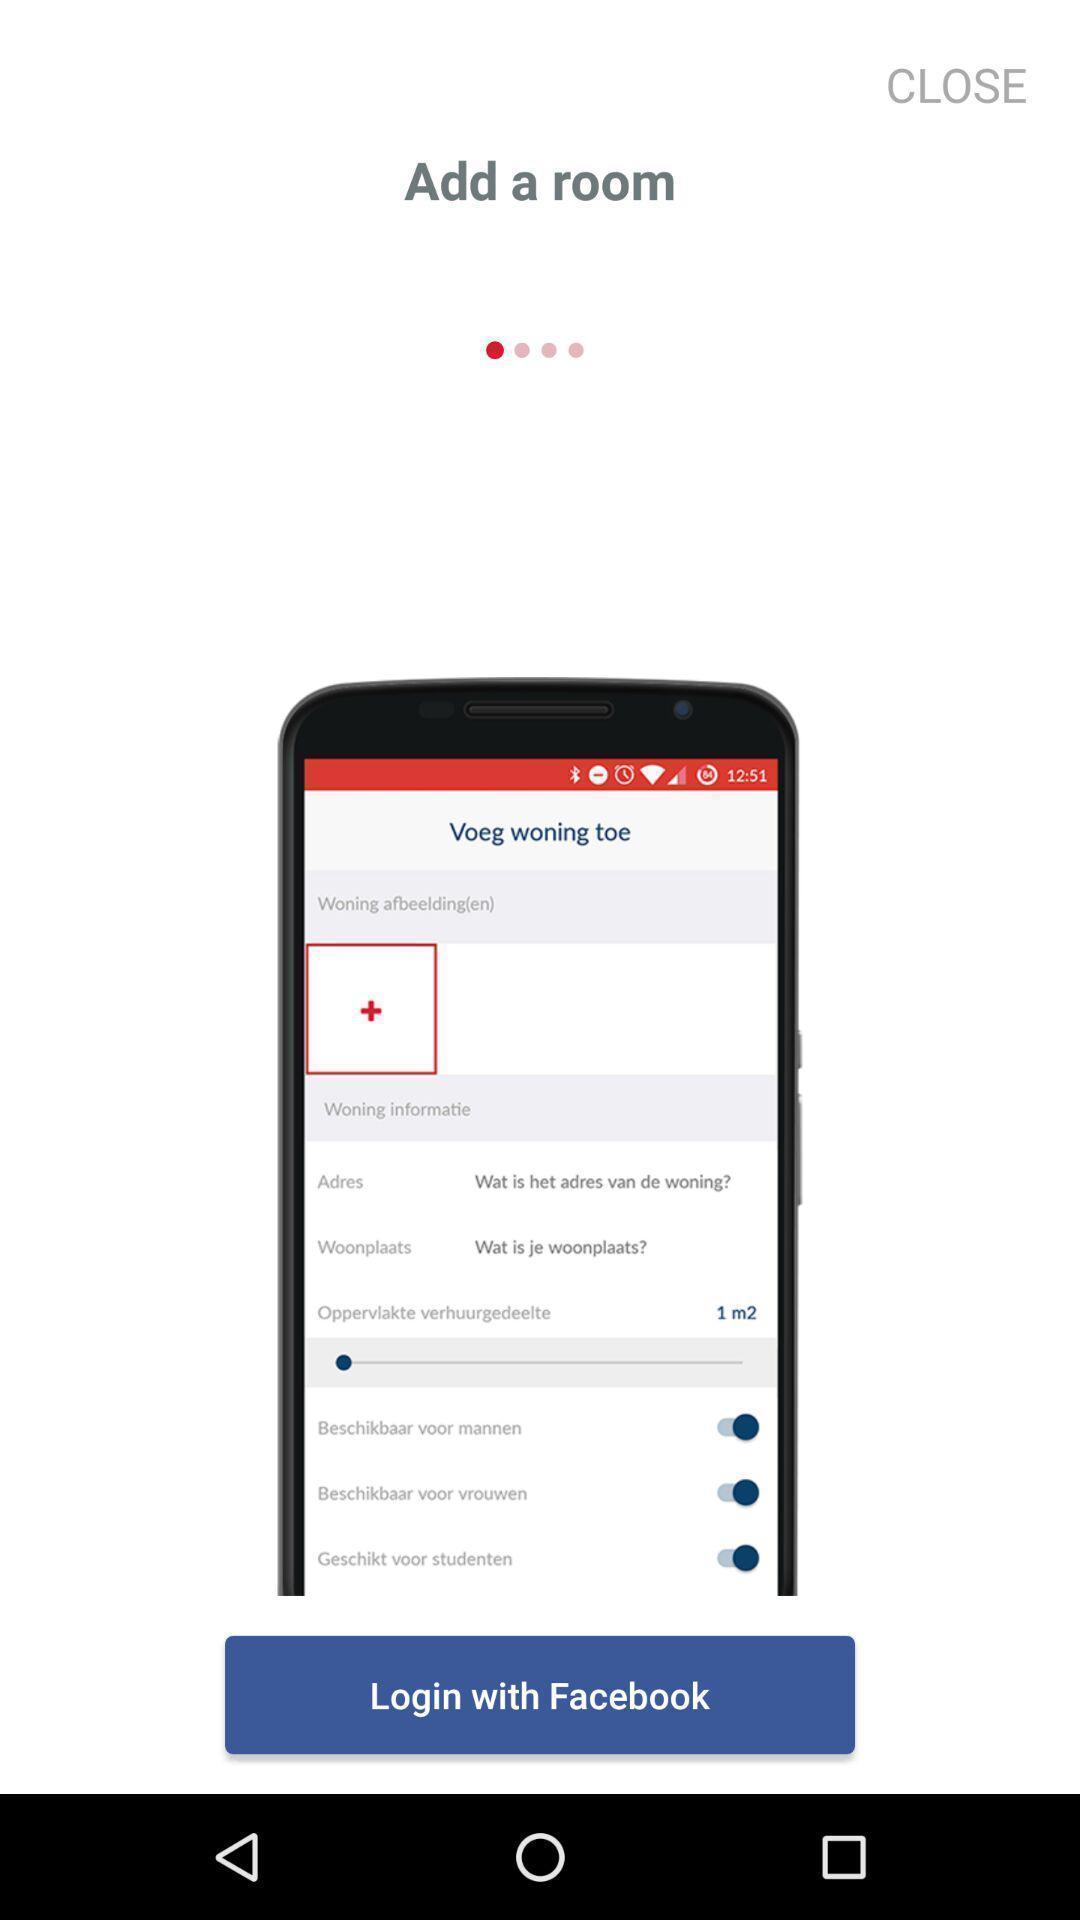What is the overall content of this screenshot? Page showing login with the social app option. 